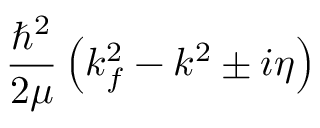<formula> <loc_0><loc_0><loc_500><loc_500>\frac { \hbar { ^ } { 2 } } { 2 \mu } \left ( k _ { f } ^ { 2 } - k ^ { 2 } \pm i \eta \right )</formula> 